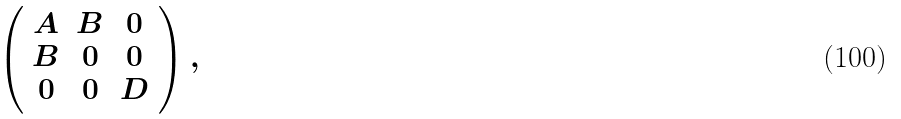Convert formula to latex. <formula><loc_0><loc_0><loc_500><loc_500>\left ( \begin{array} { c c c } A & B & 0 \\ B & 0 & 0 \\ 0 & 0 & D \end{array} \right ) ,</formula> 